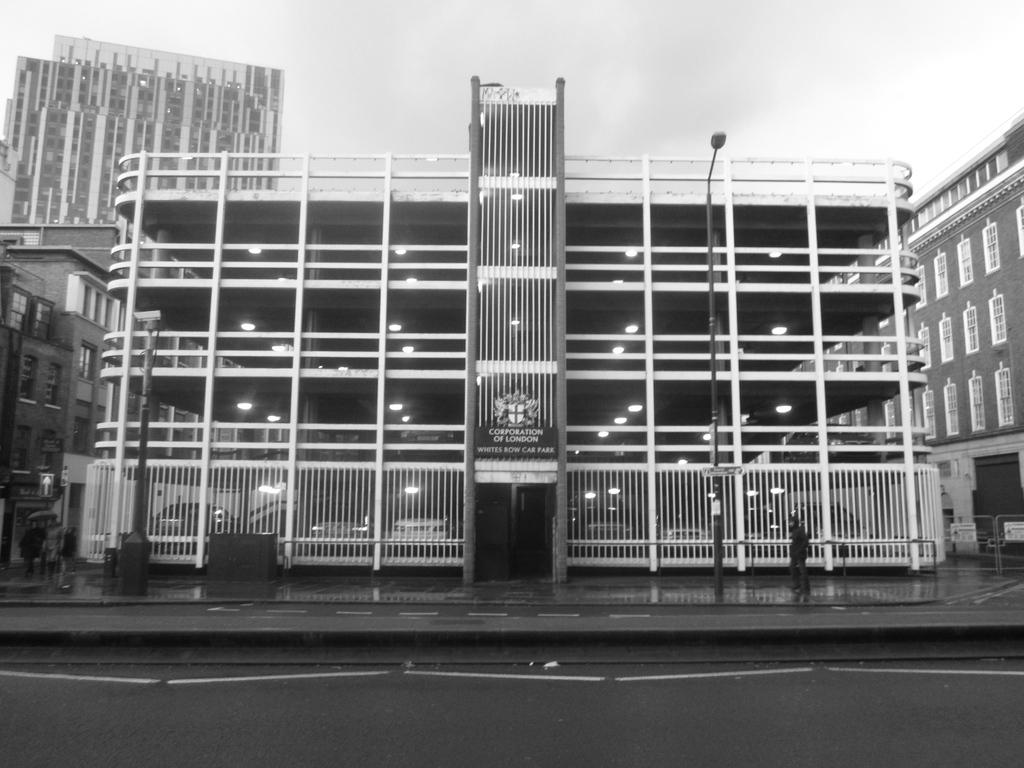What type of structures are visible in the image? There are buildings in the image. Can you describe the person in the image? A person is standing on the footpath. What other object can be seen on the footpath? There is a street light pole on the footpath. How is the image presented in terms of color? The image is in black and white color. Can you see a pig walking on the street in the image? There is no pig present in the image. Is there a snail crawling on the street light pole in the image? There is no snail present on the street light pole in the image. 